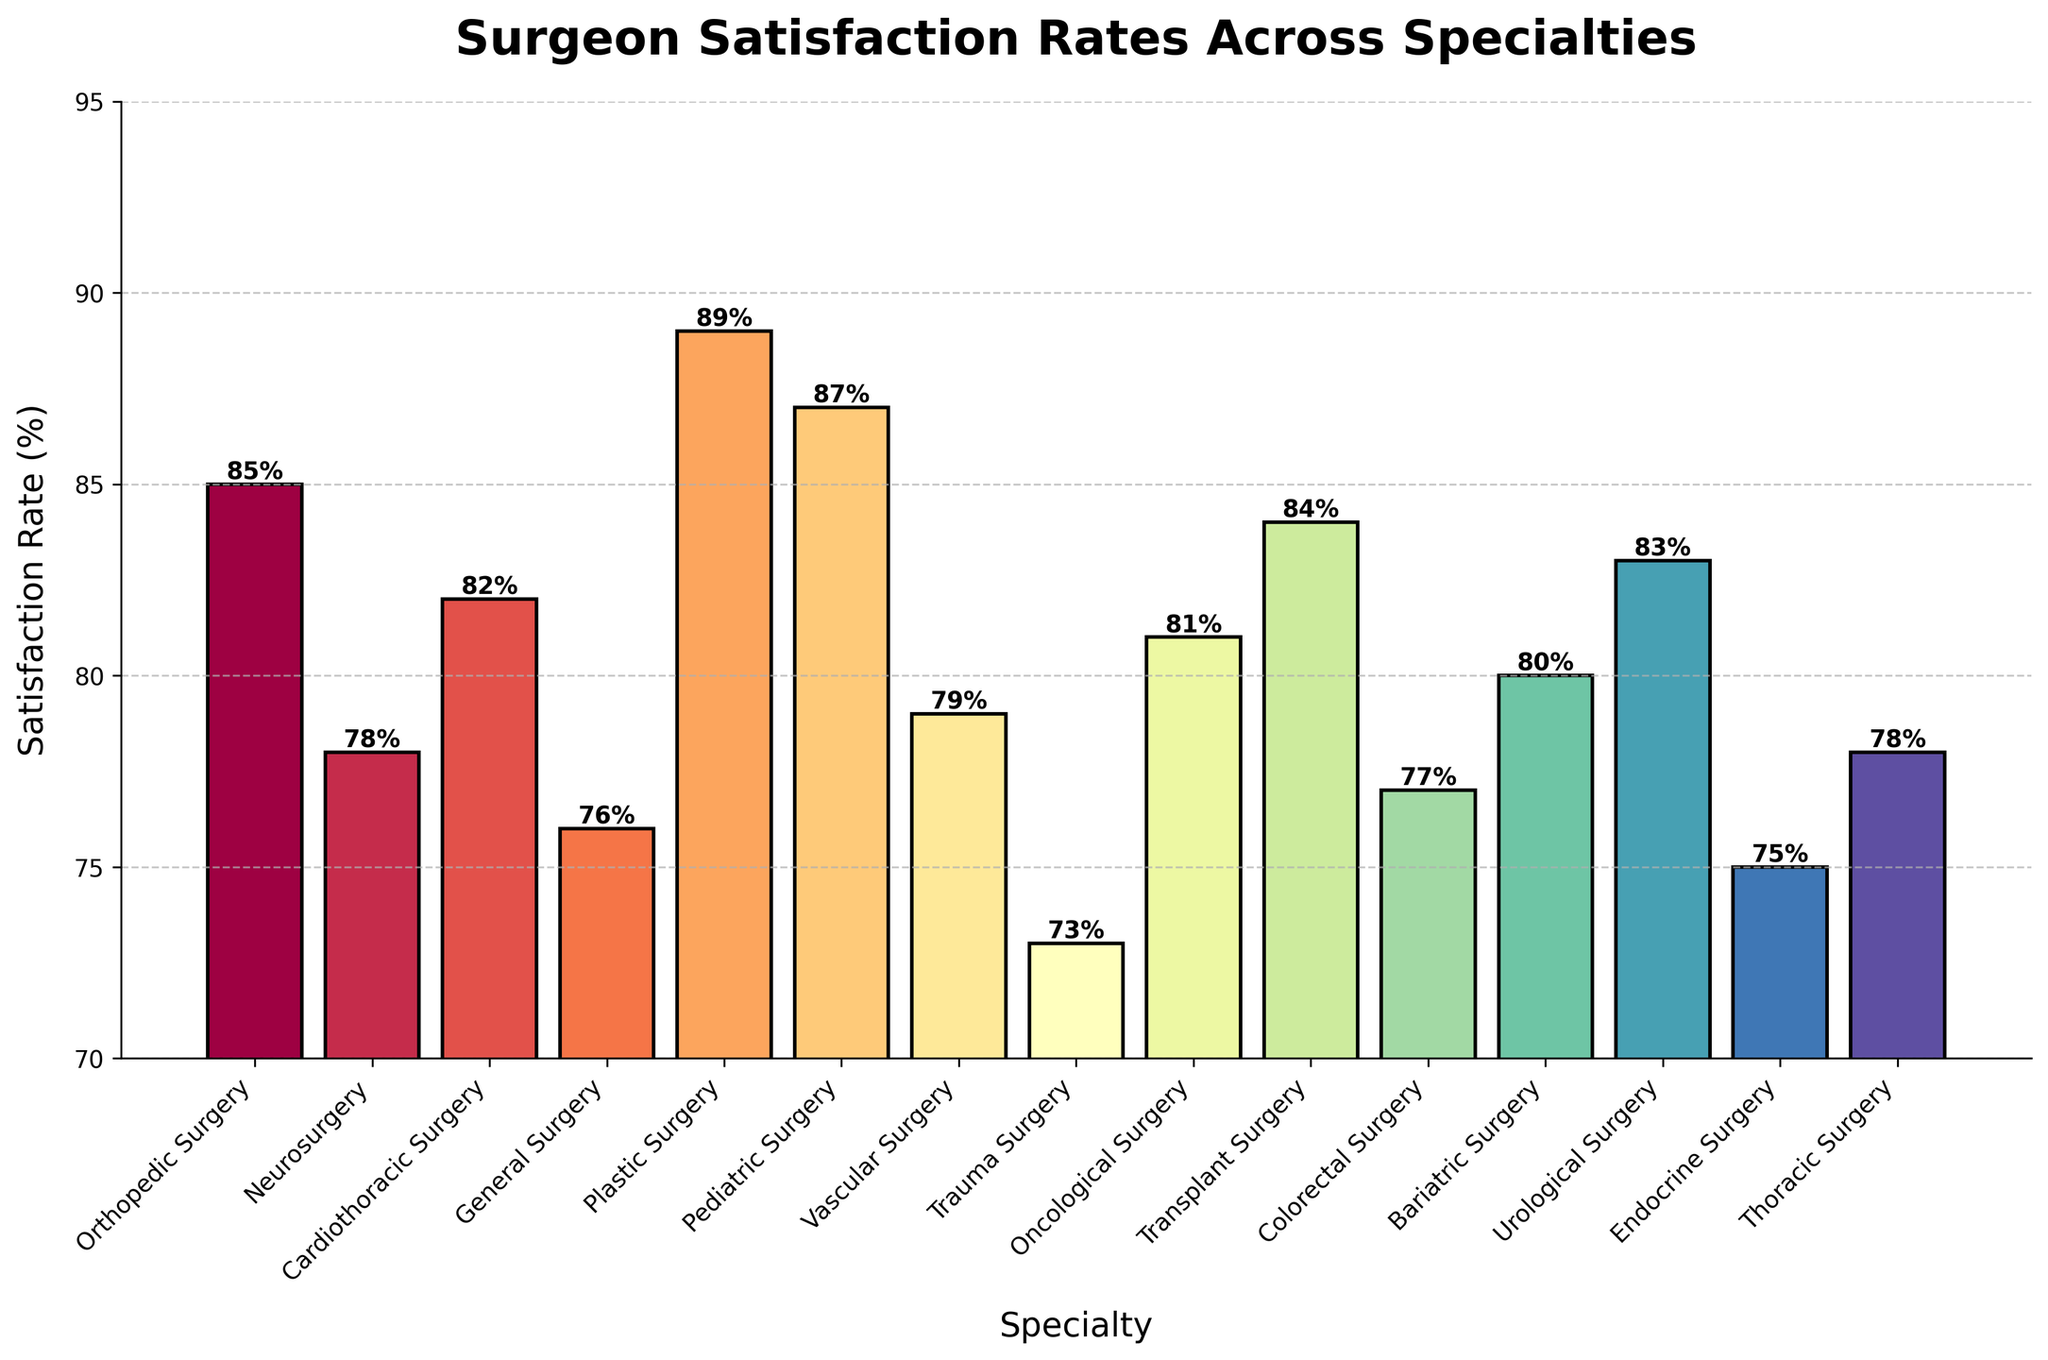What is the specialty with the highest satisfaction rate? Look at the bar chart and find the tallest bar. The tallest bar corresponds to Plastic Surgery, which has the highest satisfaction rate of 89%.
Answer: Plastic Surgery Which specialties have a satisfaction rate greater than 80%? Identify the bars that extend above the 80% line. These specialties are Orthopedic Surgery, Cardiothoracic Surgery, Plastic Surgery, Pediatric Surgery, Oncological Surgery, Transplant Surgery, Urological Surgery, and Bariatric Surgery.
Answer: Orthopedic Surgery, Cardiothoracic Surgery, Plastic Surgery, Pediatric Surgery, Oncological Surgery, Transplant Surgery, Urological Surgery, Bariatric Surgery What is the average satisfaction rate across all specialties? Sum all the satisfaction rates and then divide by the number of specialties. The total sum is 1267 and there are 15 specialties. So, the average is 1267 / 15 = 84.47.
Answer: 84.47 Which specialty has the lowest satisfaction rate and what is that rate? Look for the shortest bar on the chart, which corresponds to Trauma Surgery with a satisfaction rate of 73%.
Answer: Trauma Surgery, 73% Compare the satisfaction rates between Orthopedic Surgery and Neurosurgery. Which is higher and by how much? Find the heights of the bars for Orthopedic Surgery and Neurosurgery. Orthopedic Surgery has a satisfaction rate of 85%, and Neurosurgery has 78%. The difference is 85 - 78 = 7.
Answer: Orthopedic Surgery, 7% Which specialties have a satisfaction rate within 2% of 80%? Identify the specialties with satisfaction rates from 78% to 82%. Those are Neurosurgery (78%), Cardiothoracic Surgery (82%), Vascular Surgery (79%), and Bariatric Surgery (80%).
Answer: Neurosurgery, Cardiothoracic Surgery, Vascular Surgery, Bariatric Surgery What is the median satisfaction rate among all the specialties? List all the satisfaction rates in numerical order: 73, 75, 76, 77, 78, 78, 79, 80, 81, 82, 83, 84, 85, 87, 89. The middle value in this list is the median. Since there are 15 values, the median is the 8th value, which is 80.
Answer: 80 Which specialty is exactly in the middle of the satisfaction rate distribution? List all specialties ordered by satisfaction rate. With 15 specialties, the middle one is the 8th specialty. Ordered rates: Trauma Surgery, Endocrine Surgery, General Surgery, Colorectal Surgery, Neurosurgery, Thoracic Surgery, Vascular Surgery, Bariatric Surgery, Oncological Surgery, Cardiothoracic Surgery, Urological Surgery, Transplant Surgery, Orthopedic Surgery, Pediatric Surgery, Plastic Surgery. Bariatric Surgery is in the 8th position.
Answer: Bariatric Surgery How many specialties have a satisfaction rate less than 80%? Count the bars that fall below the 80% line. Those specialties are General Surgery, Trauma Surgery, Colorectal Surgery, Neurosurgery, Vascular Surgery, and Endocrine Surgery, totaling 6 specialties.
Answer: 6 What is the combined satisfaction rate for Pediatric Surgery and Plastic Surgery? Sum the satisfaction rates of Pediatric Surgery (87%) and Plastic Surgery (89%), which gives 87 + 89 = 176.
Answer: 176 